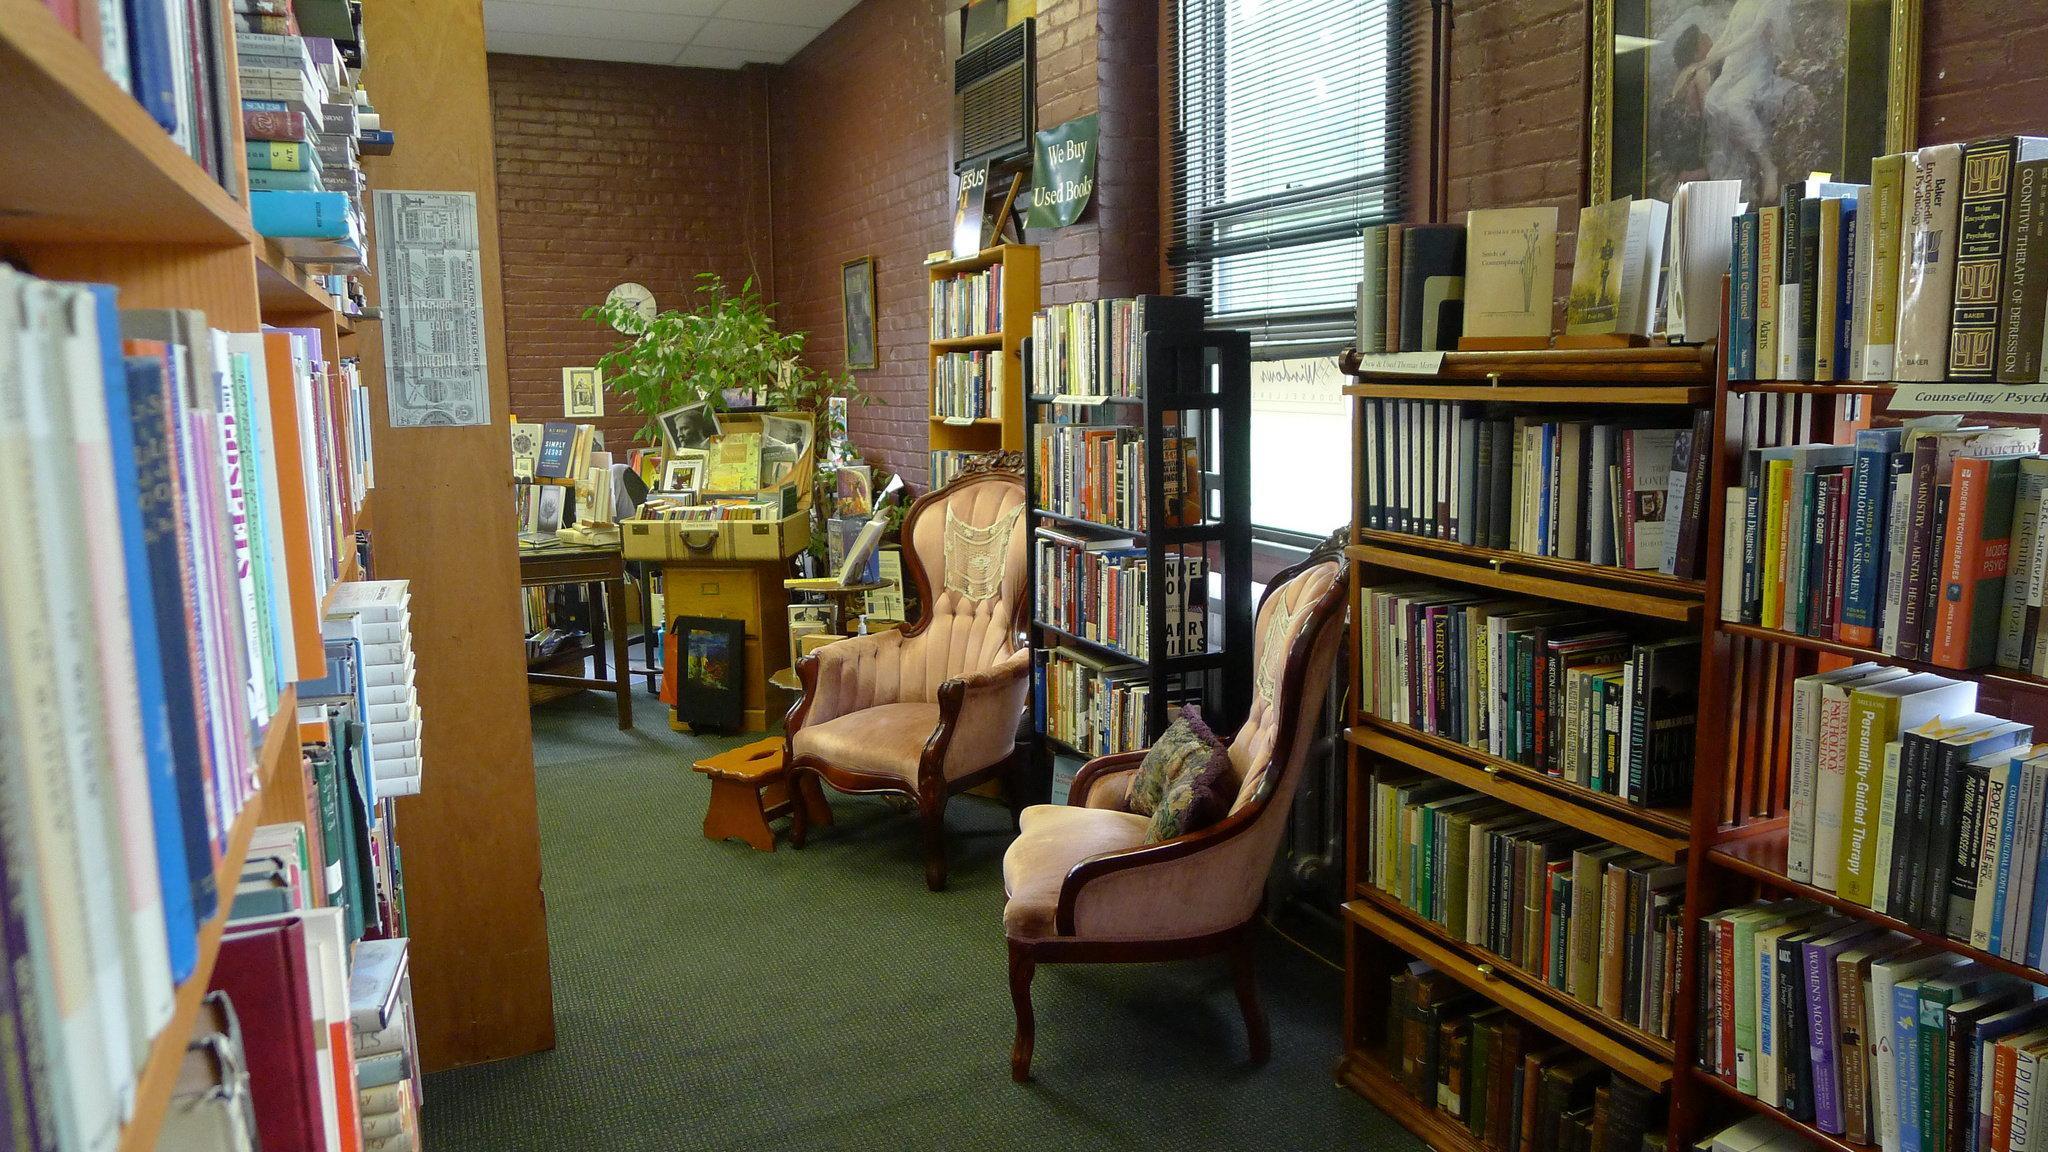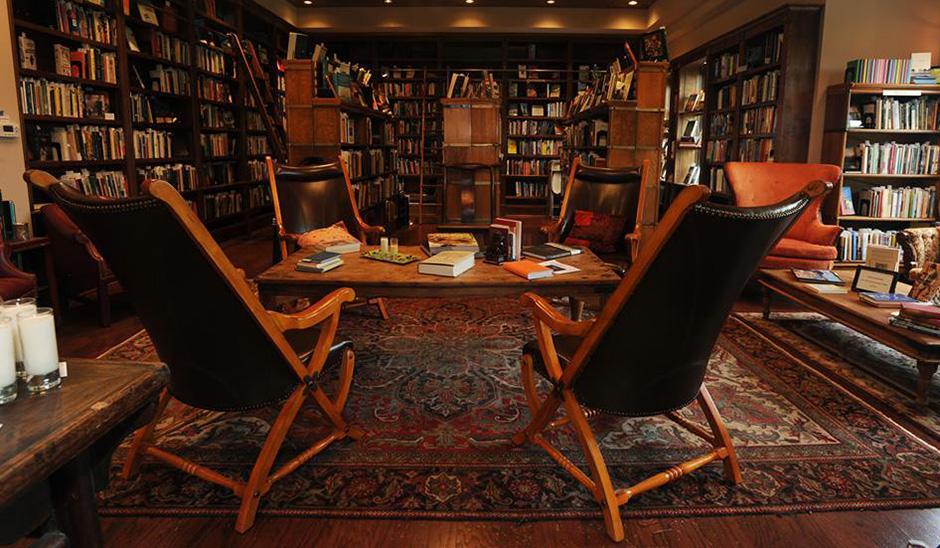The first image is the image on the left, the second image is the image on the right. Assess this claim about the two images: "A booklined reading area includes a tufted wingback chair.". Correct or not? Answer yes or no. Yes. The first image is the image on the left, the second image is the image on the right. For the images shown, is this caption "At least one blue chair gives a seating area in the bookstore." true? Answer yes or no. No. 